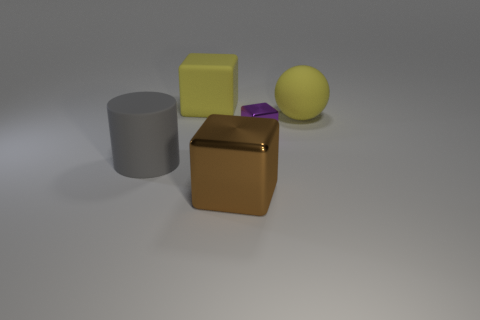What is the material of the big object that is the same color as the sphere?
Offer a very short reply. Rubber. There is a large thing that is behind the yellow matte ball; does it have the same color as the big cylinder?
Provide a succinct answer. No. There is a object that is both behind the small metallic thing and on the left side of the purple shiny object; what is it made of?
Provide a succinct answer. Rubber. Are there more big rubber cylinders than red rubber cylinders?
Your answer should be compact. Yes. The tiny metallic block left of the yellow rubber thing on the right side of the metal block behind the big brown object is what color?
Offer a terse response. Purple. Are the yellow object to the left of the big shiny thing and the cylinder made of the same material?
Offer a terse response. Yes. Are there any small objects that have the same color as the large sphere?
Make the answer very short. No. Are any blue blocks visible?
Provide a succinct answer. No. Do the block behind the yellow matte sphere and the purple metal thing have the same size?
Offer a very short reply. No. Is the number of tiny cyan matte balls less than the number of tiny shiny cubes?
Offer a very short reply. Yes. 